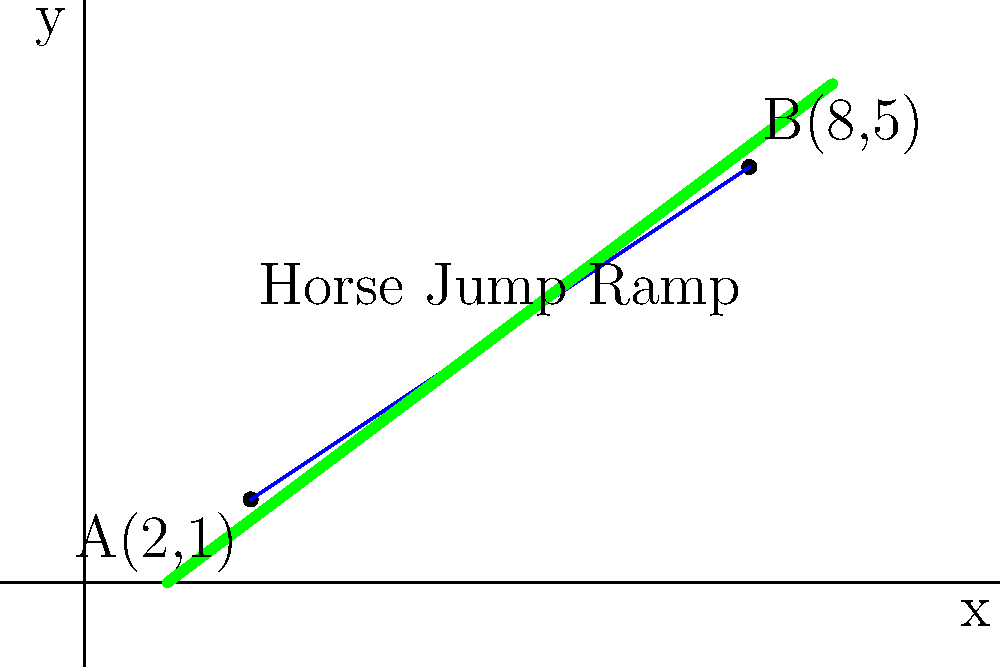As you're setting up a new horse jump ramp at the equestrian center, you need to calculate its slope. The ramp's starting point is at coordinates (2,1) and the ending point is at (8,5). What is the slope of this horse jump ramp? To calculate the slope of the horse jump ramp, we'll use the slope formula:

$$ \text{Slope} = \frac{y_2 - y_1}{x_2 - x_1} $$

Where $(x_1, y_1)$ is the starting point and $(x_2, y_2)$ is the ending point.

Given:
- Starting point A: $(2, 1)$
- Ending point B: $(8, 5)$

Let's substitute these values into the formula:

$$ \text{Slope} = \frac{5 - 1}{8 - 2} = \frac{4}{6} $$

Simplifying the fraction:

$$ \frac{4}{6} = \frac{2}{3} $$

Therefore, the slope of the horse jump ramp is $\frac{2}{3}$ or approximately 0.667.

This means for every 3 units of horizontal distance, the ramp rises 2 units vertically.
Answer: $\frac{2}{3}$ 